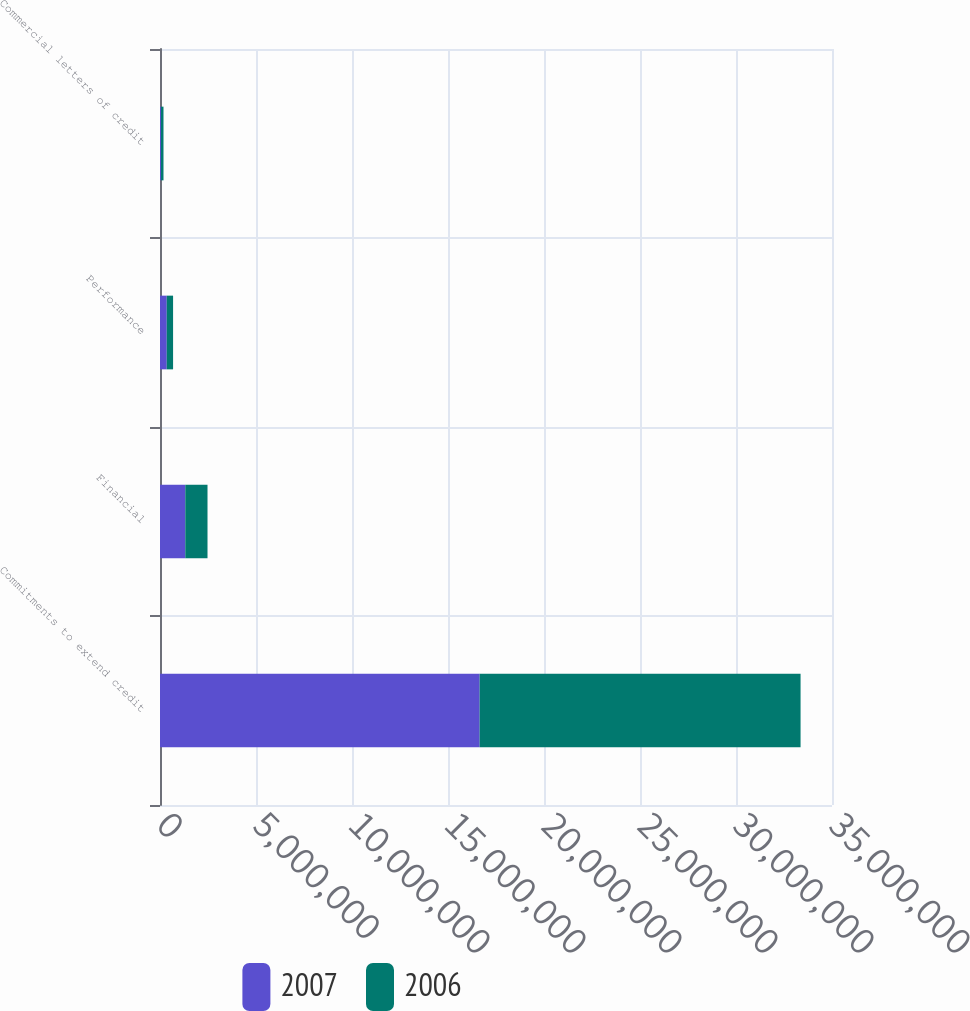Convert chart. <chart><loc_0><loc_0><loc_500><loc_500><stacked_bar_chart><ecel><fcel>Commitments to extend credit<fcel>Financial<fcel>Performance<fcel>Commercial letters of credit<nl><fcel>2007<fcel>1.66481e+07<fcel>1.3173e+06<fcel>351150<fcel>49346<nl><fcel>2006<fcel>1.67147e+07<fcel>1.1572e+06<fcel>330056<fcel>132615<nl></chart> 